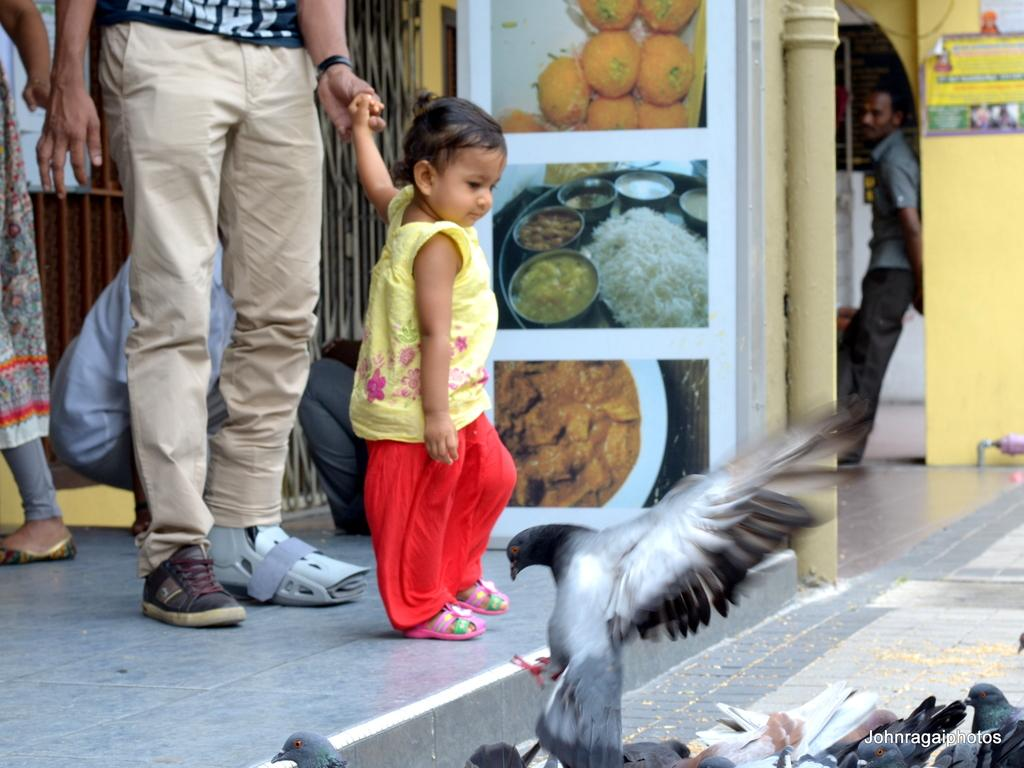Who or what can be seen in the image? There are people and birds in the image. What is located in the background of the image? There is a grill in the background of the image. What is on the wall in the image? There are posters on the wall in the image. What architectural feature is present in the image? There is a pillar in the image. What type of reaction can be seen in the notebook in the image? There is no notebook present in the image, so it is not possible to determine any reactions. 